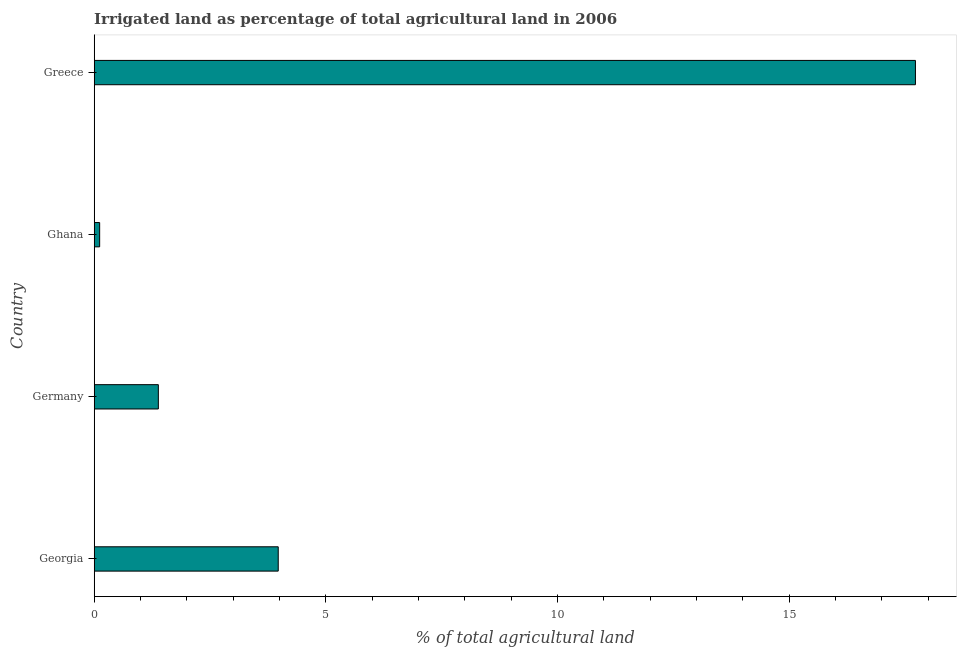Does the graph contain grids?
Your response must be concise. No. What is the title of the graph?
Ensure brevity in your answer.  Irrigated land as percentage of total agricultural land in 2006. What is the label or title of the X-axis?
Make the answer very short. % of total agricultural land. What is the percentage of agricultural irrigated land in Greece?
Give a very brief answer. 17.72. Across all countries, what is the maximum percentage of agricultural irrigated land?
Provide a short and direct response. 17.72. Across all countries, what is the minimum percentage of agricultural irrigated land?
Offer a terse response. 0.12. In which country was the percentage of agricultural irrigated land maximum?
Ensure brevity in your answer.  Greece. What is the sum of the percentage of agricultural irrigated land?
Make the answer very short. 23.2. What is the difference between the percentage of agricultural irrigated land in Germany and Ghana?
Give a very brief answer. 1.27. What is the average percentage of agricultural irrigated land per country?
Provide a succinct answer. 5.8. What is the median percentage of agricultural irrigated land?
Your answer should be compact. 2.68. What is the ratio of the percentage of agricultural irrigated land in Georgia to that in Greece?
Keep it short and to the point. 0.22. What is the difference between the highest and the second highest percentage of agricultural irrigated land?
Keep it short and to the point. 13.75. Is the sum of the percentage of agricultural irrigated land in Germany and Greece greater than the maximum percentage of agricultural irrigated land across all countries?
Your answer should be compact. Yes. Are all the bars in the graph horizontal?
Ensure brevity in your answer.  Yes. How many countries are there in the graph?
Your response must be concise. 4. Are the values on the major ticks of X-axis written in scientific E-notation?
Make the answer very short. No. What is the % of total agricultural land of Georgia?
Your response must be concise. 3.97. What is the % of total agricultural land in Germany?
Your answer should be very brief. 1.38. What is the % of total agricultural land of Ghana?
Ensure brevity in your answer.  0.12. What is the % of total agricultural land of Greece?
Give a very brief answer. 17.72. What is the difference between the % of total agricultural land in Georgia and Germany?
Keep it short and to the point. 2.59. What is the difference between the % of total agricultural land in Georgia and Ghana?
Give a very brief answer. 3.85. What is the difference between the % of total agricultural land in Georgia and Greece?
Ensure brevity in your answer.  -13.75. What is the difference between the % of total agricultural land in Germany and Ghana?
Offer a terse response. 1.27. What is the difference between the % of total agricultural land in Germany and Greece?
Offer a very short reply. -16.34. What is the difference between the % of total agricultural land in Ghana and Greece?
Your answer should be very brief. -17.6. What is the ratio of the % of total agricultural land in Georgia to that in Germany?
Make the answer very short. 2.87. What is the ratio of the % of total agricultural land in Georgia to that in Ghana?
Your answer should be compact. 33.76. What is the ratio of the % of total agricultural land in Georgia to that in Greece?
Make the answer very short. 0.22. What is the ratio of the % of total agricultural land in Germany to that in Ghana?
Make the answer very short. 11.77. What is the ratio of the % of total agricultural land in Germany to that in Greece?
Offer a terse response. 0.08. What is the ratio of the % of total agricultural land in Ghana to that in Greece?
Your response must be concise. 0.01. 